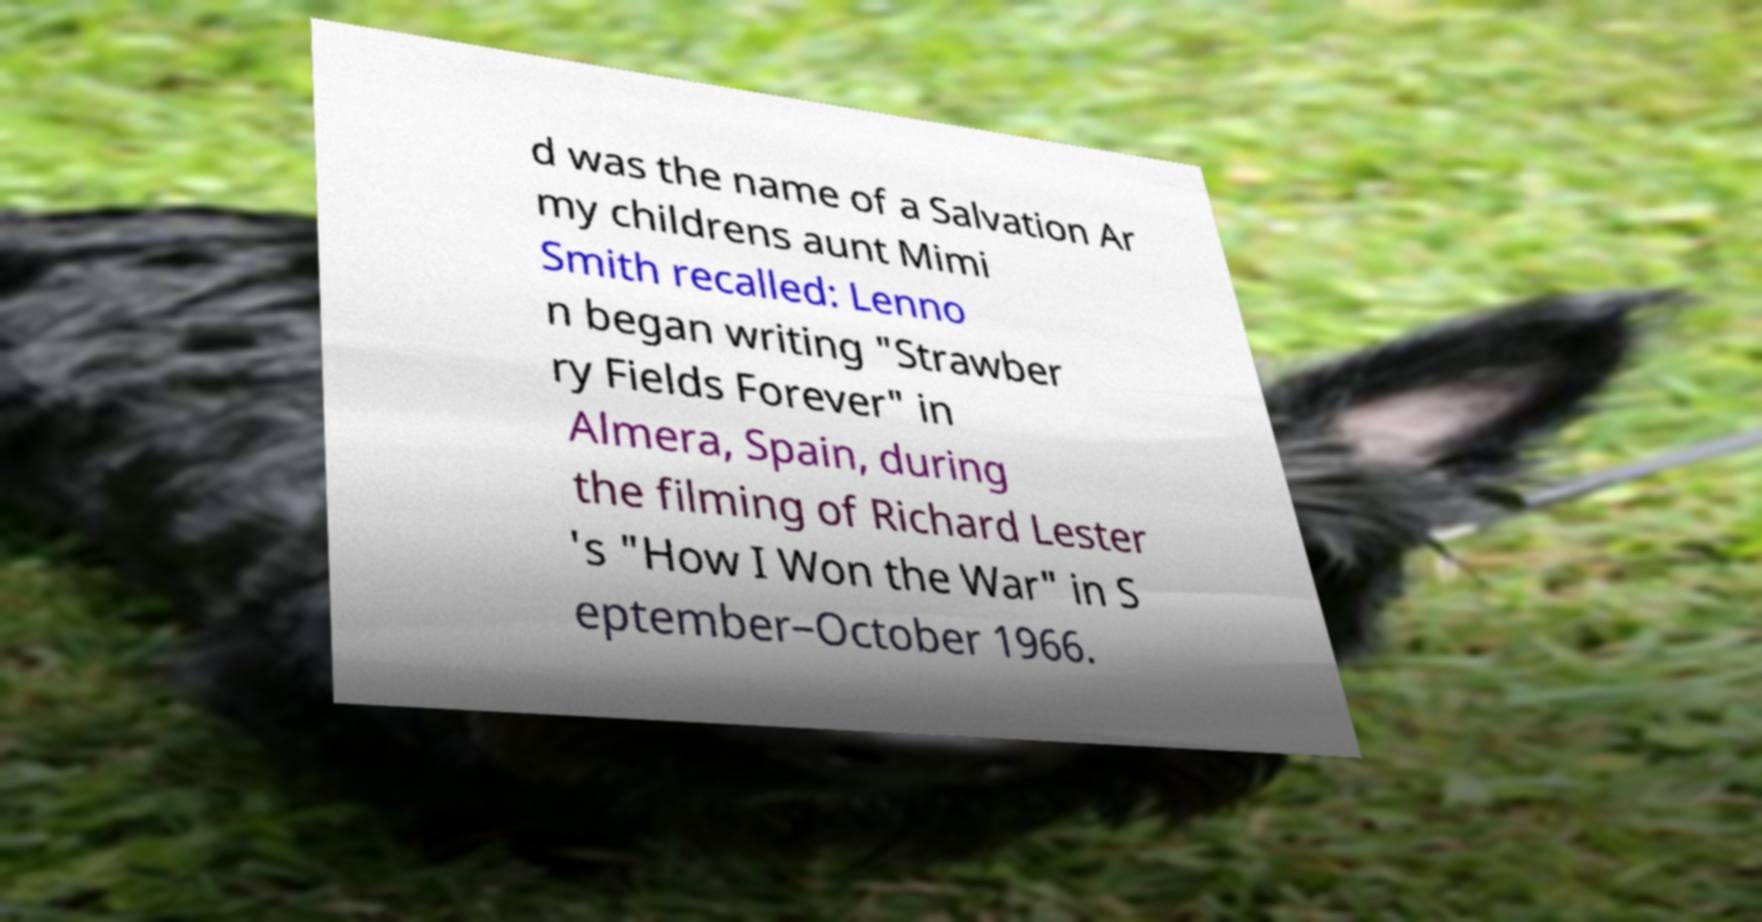I need the written content from this picture converted into text. Can you do that? d was the name of a Salvation Ar my childrens aunt Mimi Smith recalled: Lenno n began writing "Strawber ry Fields Forever" in Almera, Spain, during the filming of Richard Lester 's "How I Won the War" in S eptember–October 1966. 